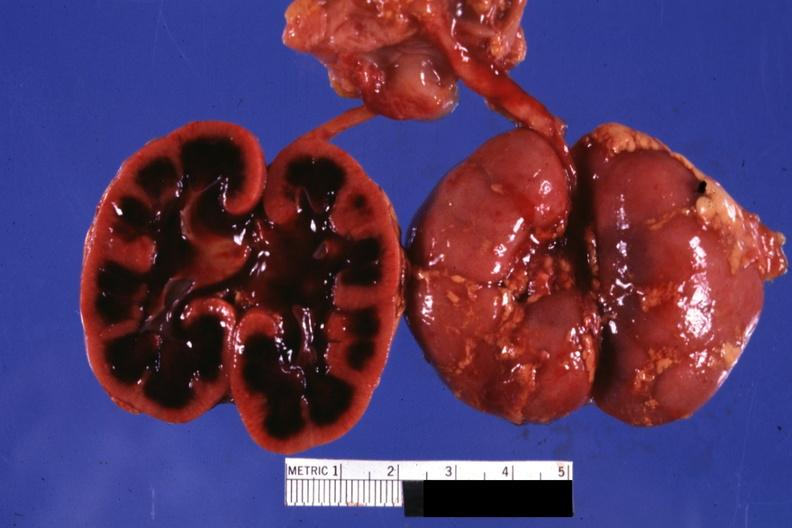what is present?
Answer the question using a single word or phrase. Kidney 